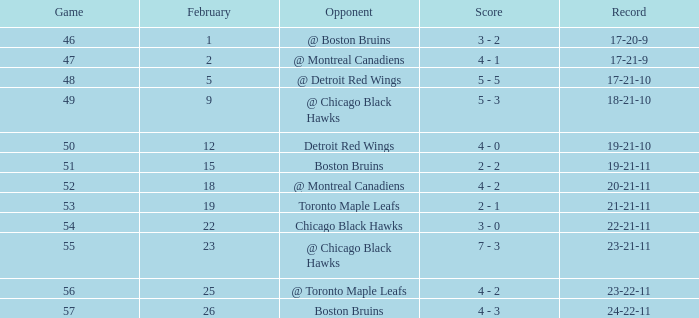What is the score of the game before 56 held after February 18 against the Chicago Black Hawks. 3 - 0. 